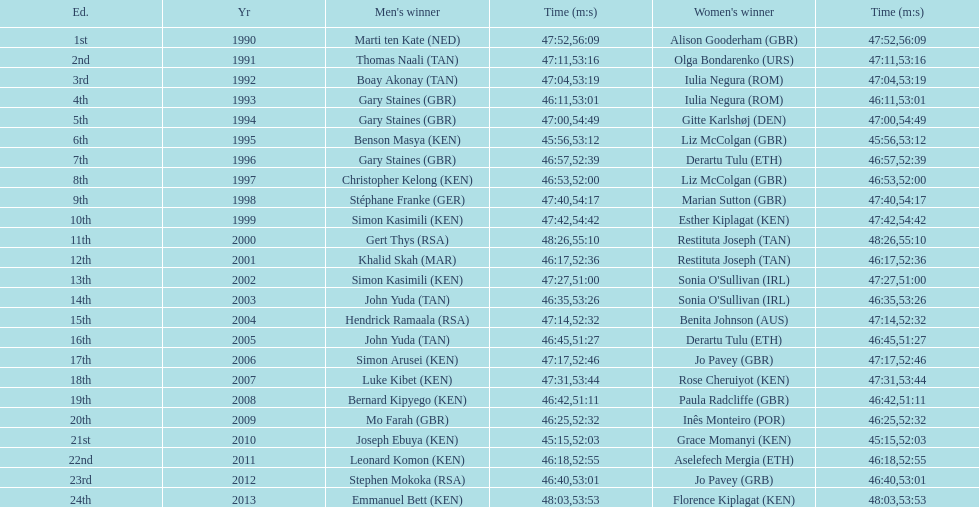What is the name of the first women's winner? Alison Gooderham. Would you mind parsing the complete table? {'header': ['Ed.', 'Yr', "Men's winner", 'Time (m:s)', "Women's winner", 'Time (m:s)'], 'rows': [['1st', '1990', 'Marti ten Kate\xa0(NED)', '47:52', 'Alison Gooderham\xa0(GBR)', '56:09'], ['2nd', '1991', 'Thomas Naali\xa0(TAN)', '47:11', 'Olga Bondarenko\xa0(URS)', '53:16'], ['3rd', '1992', 'Boay Akonay\xa0(TAN)', '47:04', 'Iulia Negura\xa0(ROM)', '53:19'], ['4th', '1993', 'Gary Staines\xa0(GBR)', '46:11', 'Iulia Negura\xa0(ROM)', '53:01'], ['5th', '1994', 'Gary Staines\xa0(GBR)', '47:00', 'Gitte Karlshøj\xa0(DEN)', '54:49'], ['6th', '1995', 'Benson Masya\xa0(KEN)', '45:56', 'Liz McColgan\xa0(GBR)', '53:12'], ['7th', '1996', 'Gary Staines\xa0(GBR)', '46:57', 'Derartu Tulu\xa0(ETH)', '52:39'], ['8th', '1997', 'Christopher Kelong\xa0(KEN)', '46:53', 'Liz McColgan\xa0(GBR)', '52:00'], ['9th', '1998', 'Stéphane Franke\xa0(GER)', '47:40', 'Marian Sutton\xa0(GBR)', '54:17'], ['10th', '1999', 'Simon Kasimili\xa0(KEN)', '47:42', 'Esther Kiplagat\xa0(KEN)', '54:42'], ['11th', '2000', 'Gert Thys\xa0(RSA)', '48:26', 'Restituta Joseph\xa0(TAN)', '55:10'], ['12th', '2001', 'Khalid Skah\xa0(MAR)', '46:17', 'Restituta Joseph\xa0(TAN)', '52:36'], ['13th', '2002', 'Simon Kasimili\xa0(KEN)', '47:27', "Sonia O'Sullivan\xa0(IRL)", '51:00'], ['14th', '2003', 'John Yuda\xa0(TAN)', '46:35', "Sonia O'Sullivan\xa0(IRL)", '53:26'], ['15th', '2004', 'Hendrick Ramaala\xa0(RSA)', '47:14', 'Benita Johnson\xa0(AUS)', '52:32'], ['16th', '2005', 'John Yuda\xa0(TAN)', '46:45', 'Derartu Tulu\xa0(ETH)', '51:27'], ['17th', '2006', 'Simon Arusei\xa0(KEN)', '47:17', 'Jo Pavey\xa0(GBR)', '52:46'], ['18th', '2007', 'Luke Kibet\xa0(KEN)', '47:31', 'Rose Cheruiyot\xa0(KEN)', '53:44'], ['19th', '2008', 'Bernard Kipyego\xa0(KEN)', '46:42', 'Paula Radcliffe\xa0(GBR)', '51:11'], ['20th', '2009', 'Mo Farah\xa0(GBR)', '46:25', 'Inês Monteiro\xa0(POR)', '52:32'], ['21st', '2010', 'Joseph Ebuya\xa0(KEN)', '45:15', 'Grace Momanyi\xa0(KEN)', '52:03'], ['22nd', '2011', 'Leonard Komon\xa0(KEN)', '46:18', 'Aselefech Mergia\xa0(ETH)', '52:55'], ['23rd', '2012', 'Stephen Mokoka\xa0(RSA)', '46:40', 'Jo Pavey\xa0(GRB)', '53:01'], ['24th', '2013', 'Emmanuel Bett\xa0(KEN)', '48:03', 'Florence Kiplagat\xa0(KEN)', '53:53']]} 